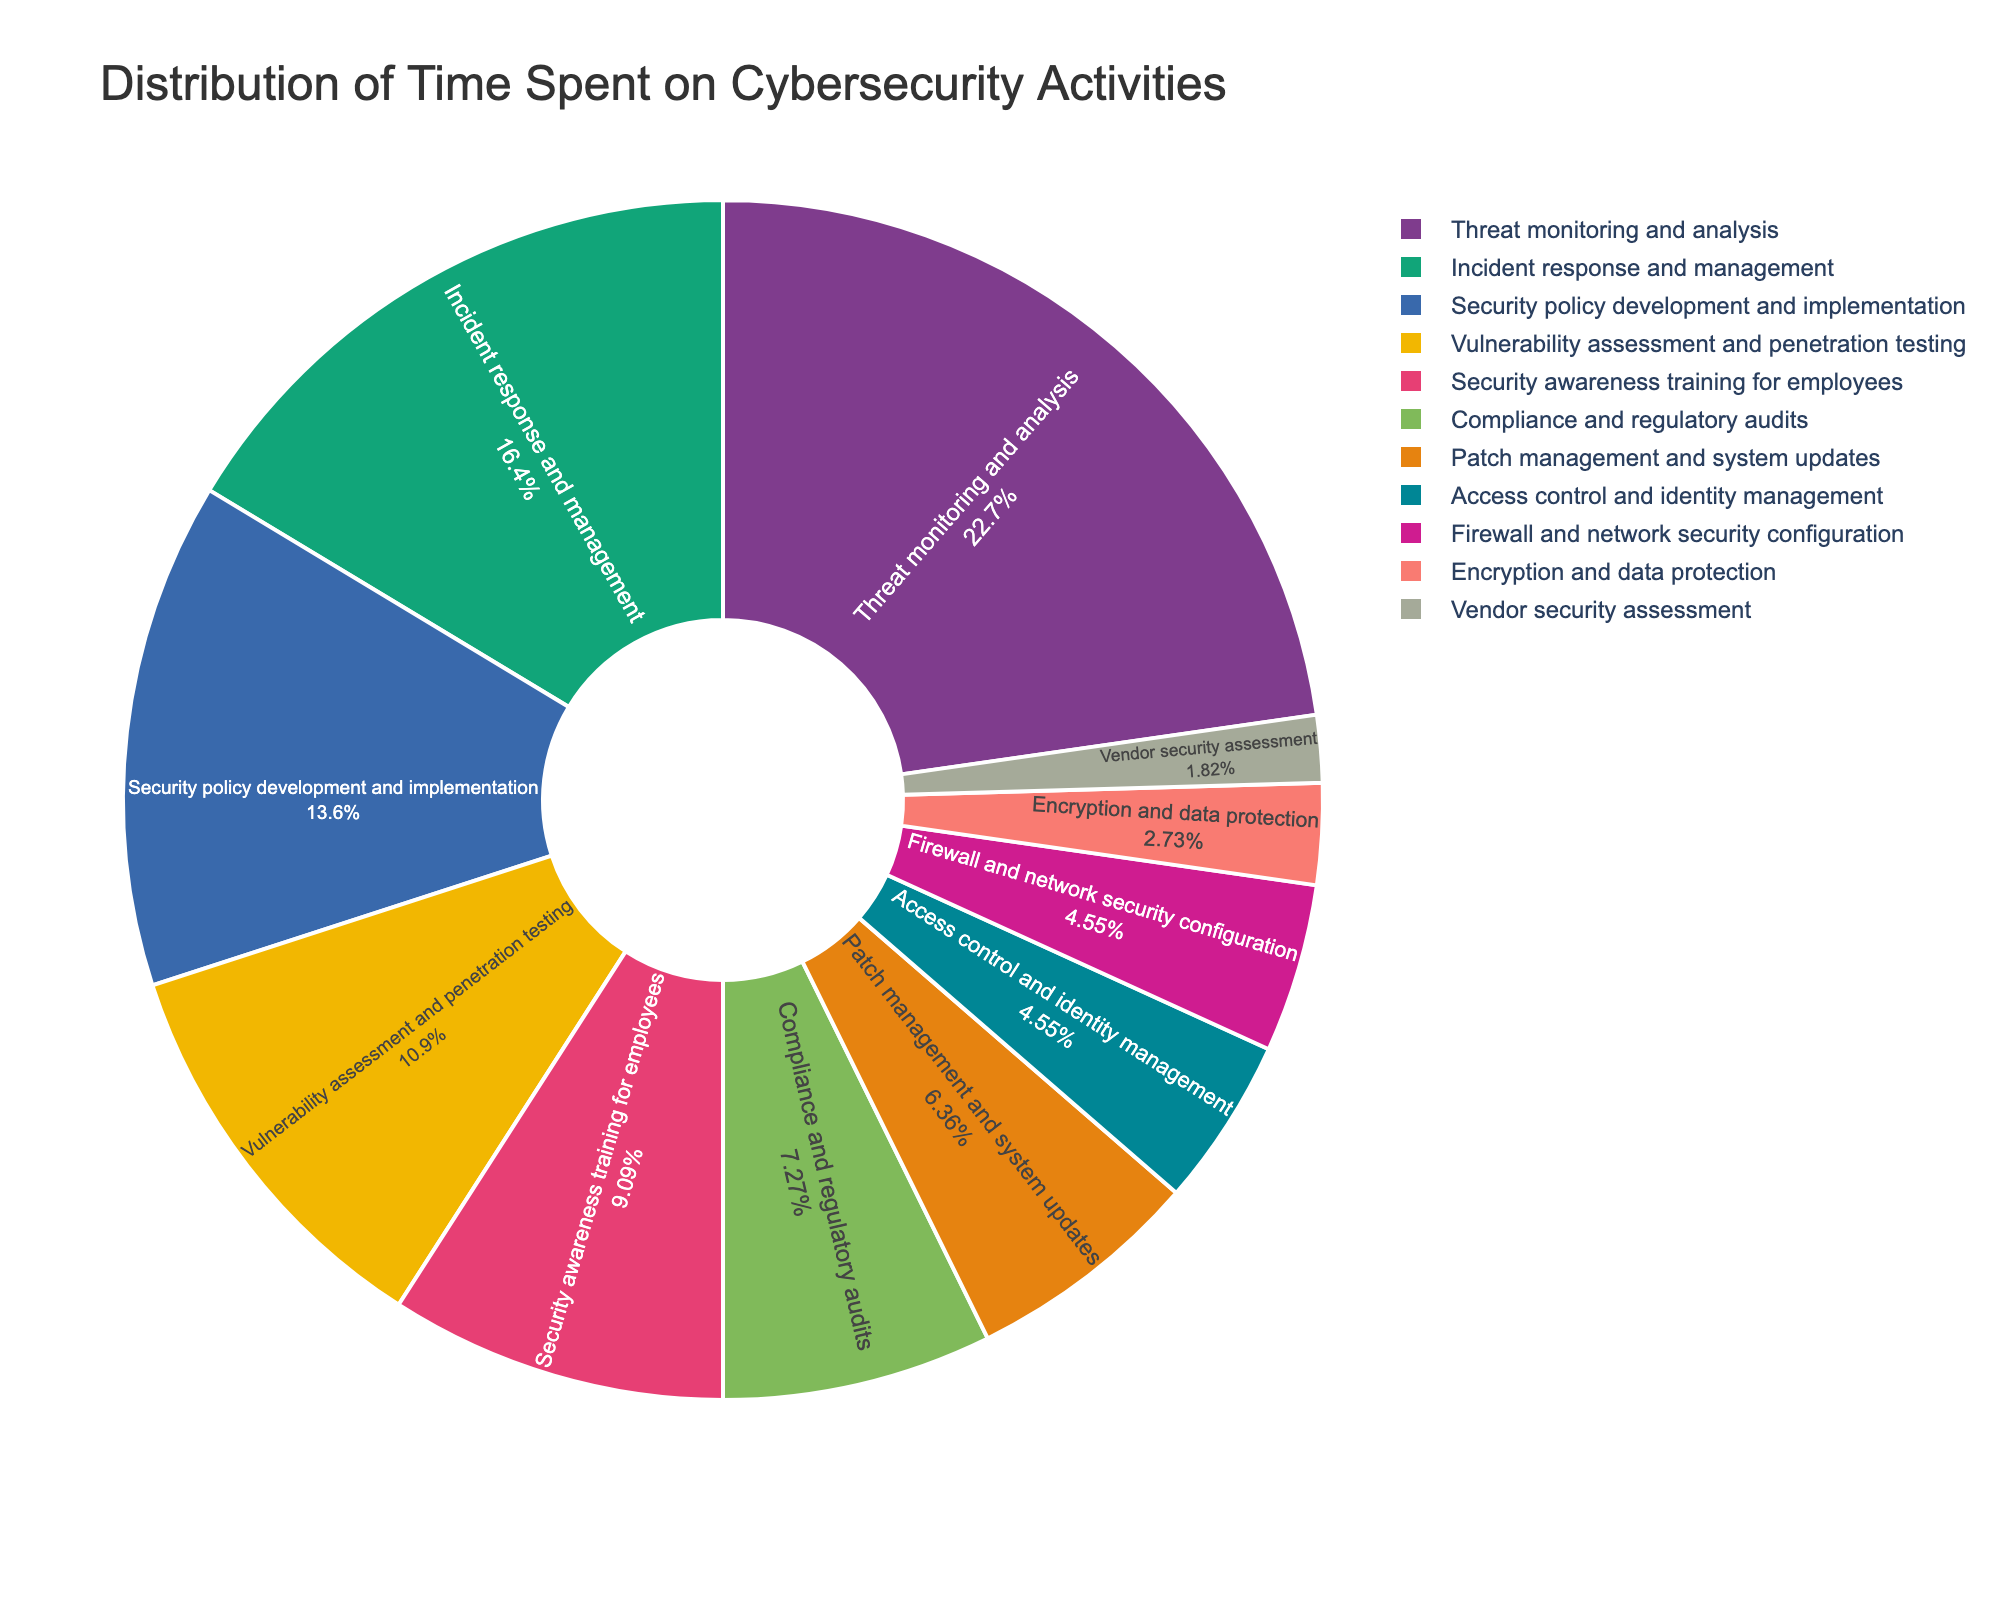What's the most time-consuming cybersecurity activity shown in the pie chart? The pie chart indicates the percentage of time spent on various cybersecurity activities. The largest segment represents the most time-consuming activity. Here, "Threat monitoring and analysis" has the highest percentage at 25%.
Answer: Threat monitoring and analysis How many activities have a time percentage of less than 5%? We need to identify and count all segments representing activities with less than 5% in the pie chart. The segments for "Access control and identity management," "Firewall and network security configuration," "Encryption and data protection," and "Vendor security assessment" all fall into this category. There are four activities in total.
Answer: 4 Which activity consumes more time: Patch management and system updates or Security awareness training for employees? By comparing the respective segments in the pie chart, "Patch management and system updates" has 7%, whereas "Security awareness training for employees" has 10%. Thus, "Security awareness training for employees" consumes more time.
Answer: Security awareness training for employees What is the combined percentage of time spent on Security policy development, Compliance audits, and Vendor security assessment? First, we identify the percentages of these activities: "Security policy development and implementation" is 15%, "Compliance and regulatory audits" is 8%, and "Vendor security assessment" is 2%. Adding these amounts: 15% + 8% + 2% = 25%.
Answer: 25% Is the percentage of time spent on Incident response and management greater than the combined percentage of Access control and Identity management, and Encryption and data protection? "Incident response and management" takes up 18%. The combined percentage for "Access control and identity management" (5%) and "Encryption and data protection" (3%) is 5% + 3% = 8%. Since 18% is greater than 8%, the percentage for Incident response and management is greater.
Answer: Yes What's the difference between the time spent on Threat monitoring and analysis and Firewall and network security configuration? "Threat monitoring and analysis" has a percentage of 25%, while "Firewall and network security configuration" is at 5%. The difference between them is 25% - 5% = 20%.
Answer: 20% Is the segment representing Vulnerability assessment and penetration testing larger or smaller than the segment representing Security policy development and implementation? "Vulnerability assessment and penetration testing" has a percentage of 12%, while "Security policy development and implementation" stands at 15%. Therefore, the segment for "Vulnerability assessment and penetration testing" is smaller.
Answer: Smaller Considering the total percentage for activities excluding "Threat monitoring and analysis," what is the remaining percentage of time spent? The total percentage for all activities is 100%. By excluding "Threat monitoring and analysis" which is 25%, we subtract this from the total: 100% - 25% = 75%.
Answer: 75% 